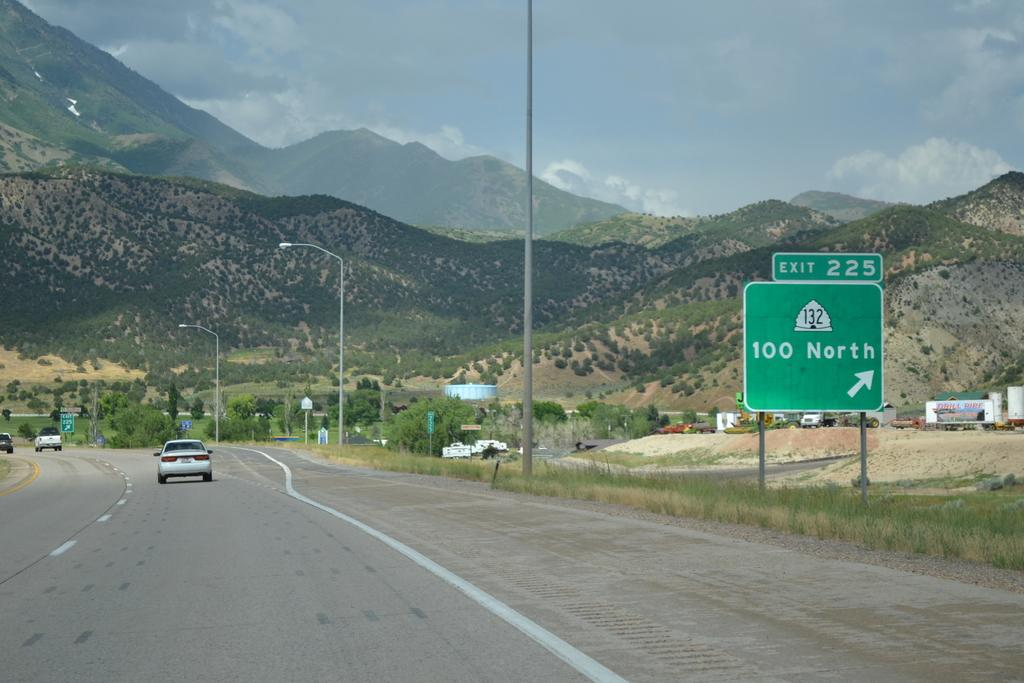<image>
Create a compact narrative representing the image presented. A highway into the mountains where exit 225 is approaching, the 100 North. 